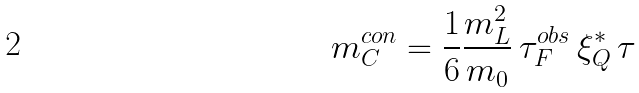Convert formula to latex. <formula><loc_0><loc_0><loc_500><loc_500>m _ { C } ^ { c o n } = \frac { 1 } { 6 } \frac { m _ { L } ^ { 2 } } { m _ { 0 } } \, \tau _ { F } ^ { o b s } \, \xi _ { Q } ^ { * } \, \tau</formula> 